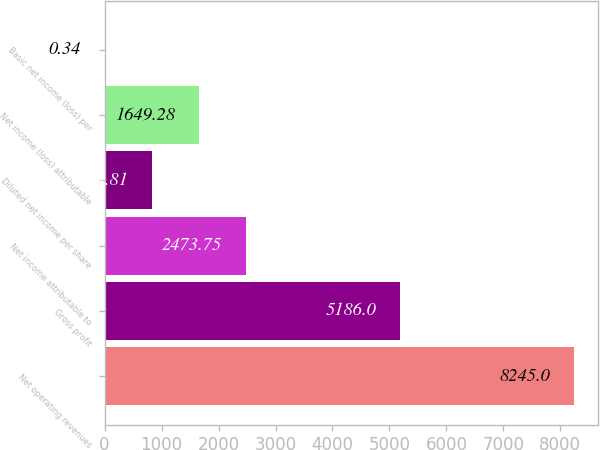Convert chart. <chart><loc_0><loc_0><loc_500><loc_500><bar_chart><fcel>Net operating revenues<fcel>Gross profit<fcel>Net income attributable to<fcel>Diluted net income per share<fcel>Net income (loss) attributable<fcel>Basic net income (loss) per<nl><fcel>8245<fcel>5186<fcel>2473.75<fcel>824.81<fcel>1649.28<fcel>0.34<nl></chart> 